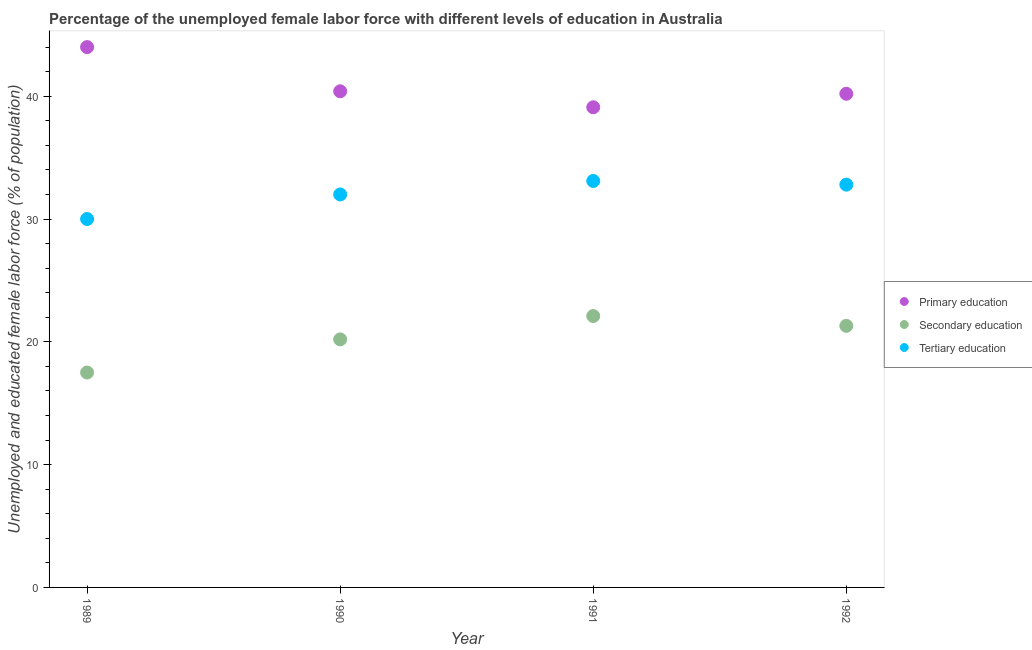What is the percentage of female labor force who received secondary education in 1990?
Keep it short and to the point. 20.2. Across all years, what is the maximum percentage of female labor force who received secondary education?
Provide a succinct answer. 22.1. Across all years, what is the minimum percentage of female labor force who received tertiary education?
Your response must be concise. 30. In which year was the percentage of female labor force who received secondary education maximum?
Make the answer very short. 1991. What is the total percentage of female labor force who received tertiary education in the graph?
Offer a very short reply. 127.9. What is the difference between the percentage of female labor force who received secondary education in 1989 and that in 1992?
Provide a succinct answer. -3.8. What is the difference between the percentage of female labor force who received tertiary education in 1990 and the percentage of female labor force who received secondary education in 1992?
Keep it short and to the point. 10.7. What is the average percentage of female labor force who received primary education per year?
Keep it short and to the point. 40.93. In the year 1992, what is the difference between the percentage of female labor force who received secondary education and percentage of female labor force who received primary education?
Your answer should be very brief. -18.9. In how many years, is the percentage of female labor force who received tertiary education greater than 10 %?
Your answer should be compact. 4. What is the ratio of the percentage of female labor force who received primary education in 1989 to that in 1992?
Your response must be concise. 1.09. Is the percentage of female labor force who received secondary education in 1990 less than that in 1992?
Your response must be concise. Yes. Is the difference between the percentage of female labor force who received primary education in 1989 and 1990 greater than the difference between the percentage of female labor force who received secondary education in 1989 and 1990?
Give a very brief answer. Yes. What is the difference between the highest and the second highest percentage of female labor force who received tertiary education?
Ensure brevity in your answer.  0.3. What is the difference between the highest and the lowest percentage of female labor force who received tertiary education?
Provide a succinct answer. 3.1. Is it the case that in every year, the sum of the percentage of female labor force who received primary education and percentage of female labor force who received secondary education is greater than the percentage of female labor force who received tertiary education?
Provide a short and direct response. Yes. How many years are there in the graph?
Your response must be concise. 4. What is the difference between two consecutive major ticks on the Y-axis?
Give a very brief answer. 10. Are the values on the major ticks of Y-axis written in scientific E-notation?
Your answer should be very brief. No. Where does the legend appear in the graph?
Your response must be concise. Center right. How many legend labels are there?
Ensure brevity in your answer.  3. How are the legend labels stacked?
Provide a short and direct response. Vertical. What is the title of the graph?
Your answer should be very brief. Percentage of the unemployed female labor force with different levels of education in Australia. Does "Errors" appear as one of the legend labels in the graph?
Make the answer very short. No. What is the label or title of the X-axis?
Give a very brief answer. Year. What is the label or title of the Y-axis?
Your response must be concise. Unemployed and educated female labor force (% of population). What is the Unemployed and educated female labor force (% of population) of Tertiary education in 1989?
Offer a terse response. 30. What is the Unemployed and educated female labor force (% of population) of Primary education in 1990?
Offer a terse response. 40.4. What is the Unemployed and educated female labor force (% of population) in Secondary education in 1990?
Your answer should be very brief. 20.2. What is the Unemployed and educated female labor force (% of population) in Primary education in 1991?
Offer a terse response. 39.1. What is the Unemployed and educated female labor force (% of population) in Secondary education in 1991?
Provide a short and direct response. 22.1. What is the Unemployed and educated female labor force (% of population) of Tertiary education in 1991?
Your answer should be compact. 33.1. What is the Unemployed and educated female labor force (% of population) in Primary education in 1992?
Provide a short and direct response. 40.2. What is the Unemployed and educated female labor force (% of population) of Secondary education in 1992?
Your answer should be compact. 21.3. What is the Unemployed and educated female labor force (% of population) of Tertiary education in 1992?
Keep it short and to the point. 32.8. Across all years, what is the maximum Unemployed and educated female labor force (% of population) of Primary education?
Offer a very short reply. 44. Across all years, what is the maximum Unemployed and educated female labor force (% of population) of Secondary education?
Provide a short and direct response. 22.1. Across all years, what is the maximum Unemployed and educated female labor force (% of population) of Tertiary education?
Your answer should be very brief. 33.1. Across all years, what is the minimum Unemployed and educated female labor force (% of population) in Primary education?
Offer a very short reply. 39.1. Across all years, what is the minimum Unemployed and educated female labor force (% of population) of Secondary education?
Offer a terse response. 17.5. Across all years, what is the minimum Unemployed and educated female labor force (% of population) in Tertiary education?
Your answer should be very brief. 30. What is the total Unemployed and educated female labor force (% of population) of Primary education in the graph?
Offer a very short reply. 163.7. What is the total Unemployed and educated female labor force (% of population) in Secondary education in the graph?
Provide a succinct answer. 81.1. What is the total Unemployed and educated female labor force (% of population) in Tertiary education in the graph?
Provide a short and direct response. 127.9. What is the difference between the Unemployed and educated female labor force (% of population) of Primary education in 1989 and that in 1992?
Ensure brevity in your answer.  3.8. What is the difference between the Unemployed and educated female labor force (% of population) of Secondary education in 1989 and that in 1992?
Give a very brief answer. -3.8. What is the difference between the Unemployed and educated female labor force (% of population) of Tertiary education in 1989 and that in 1992?
Ensure brevity in your answer.  -2.8. What is the difference between the Unemployed and educated female labor force (% of population) of Primary education in 1990 and that in 1991?
Give a very brief answer. 1.3. What is the difference between the Unemployed and educated female labor force (% of population) in Tertiary education in 1990 and that in 1991?
Ensure brevity in your answer.  -1.1. What is the difference between the Unemployed and educated female labor force (% of population) in Primary education in 1990 and that in 1992?
Keep it short and to the point. 0.2. What is the difference between the Unemployed and educated female labor force (% of population) of Tertiary education in 1990 and that in 1992?
Make the answer very short. -0.8. What is the difference between the Unemployed and educated female labor force (% of population) of Primary education in 1989 and the Unemployed and educated female labor force (% of population) of Secondary education in 1990?
Provide a succinct answer. 23.8. What is the difference between the Unemployed and educated female labor force (% of population) in Secondary education in 1989 and the Unemployed and educated female labor force (% of population) in Tertiary education in 1990?
Ensure brevity in your answer.  -14.5. What is the difference between the Unemployed and educated female labor force (% of population) in Primary education in 1989 and the Unemployed and educated female labor force (% of population) in Secondary education in 1991?
Provide a succinct answer. 21.9. What is the difference between the Unemployed and educated female labor force (% of population) in Secondary education in 1989 and the Unemployed and educated female labor force (% of population) in Tertiary education in 1991?
Ensure brevity in your answer.  -15.6. What is the difference between the Unemployed and educated female labor force (% of population) in Primary education in 1989 and the Unemployed and educated female labor force (% of population) in Secondary education in 1992?
Keep it short and to the point. 22.7. What is the difference between the Unemployed and educated female labor force (% of population) in Primary education in 1989 and the Unemployed and educated female labor force (% of population) in Tertiary education in 1992?
Provide a succinct answer. 11.2. What is the difference between the Unemployed and educated female labor force (% of population) of Secondary education in 1989 and the Unemployed and educated female labor force (% of population) of Tertiary education in 1992?
Offer a terse response. -15.3. What is the difference between the Unemployed and educated female labor force (% of population) of Primary education in 1990 and the Unemployed and educated female labor force (% of population) of Tertiary education in 1992?
Provide a short and direct response. 7.6. What is the average Unemployed and educated female labor force (% of population) of Primary education per year?
Your answer should be compact. 40.92. What is the average Unemployed and educated female labor force (% of population) in Secondary education per year?
Your response must be concise. 20.27. What is the average Unemployed and educated female labor force (% of population) of Tertiary education per year?
Provide a short and direct response. 31.98. In the year 1989, what is the difference between the Unemployed and educated female labor force (% of population) in Primary education and Unemployed and educated female labor force (% of population) in Secondary education?
Your answer should be compact. 26.5. In the year 1989, what is the difference between the Unemployed and educated female labor force (% of population) of Primary education and Unemployed and educated female labor force (% of population) of Tertiary education?
Your response must be concise. 14. In the year 1989, what is the difference between the Unemployed and educated female labor force (% of population) in Secondary education and Unemployed and educated female labor force (% of population) in Tertiary education?
Give a very brief answer. -12.5. In the year 1990, what is the difference between the Unemployed and educated female labor force (% of population) in Primary education and Unemployed and educated female labor force (% of population) in Secondary education?
Your response must be concise. 20.2. In the year 1991, what is the difference between the Unemployed and educated female labor force (% of population) of Primary education and Unemployed and educated female labor force (% of population) of Secondary education?
Provide a short and direct response. 17. In the year 1991, what is the difference between the Unemployed and educated female labor force (% of population) in Primary education and Unemployed and educated female labor force (% of population) in Tertiary education?
Provide a short and direct response. 6. In the year 1992, what is the difference between the Unemployed and educated female labor force (% of population) in Primary education and Unemployed and educated female labor force (% of population) in Secondary education?
Provide a succinct answer. 18.9. What is the ratio of the Unemployed and educated female labor force (% of population) of Primary education in 1989 to that in 1990?
Keep it short and to the point. 1.09. What is the ratio of the Unemployed and educated female labor force (% of population) in Secondary education in 1989 to that in 1990?
Your answer should be compact. 0.87. What is the ratio of the Unemployed and educated female labor force (% of population) in Tertiary education in 1989 to that in 1990?
Provide a short and direct response. 0.94. What is the ratio of the Unemployed and educated female labor force (% of population) in Primary education in 1989 to that in 1991?
Keep it short and to the point. 1.13. What is the ratio of the Unemployed and educated female labor force (% of population) in Secondary education in 1989 to that in 1991?
Make the answer very short. 0.79. What is the ratio of the Unemployed and educated female labor force (% of population) of Tertiary education in 1989 to that in 1991?
Make the answer very short. 0.91. What is the ratio of the Unemployed and educated female labor force (% of population) of Primary education in 1989 to that in 1992?
Your response must be concise. 1.09. What is the ratio of the Unemployed and educated female labor force (% of population) of Secondary education in 1989 to that in 1992?
Provide a succinct answer. 0.82. What is the ratio of the Unemployed and educated female labor force (% of population) of Tertiary education in 1989 to that in 1992?
Provide a succinct answer. 0.91. What is the ratio of the Unemployed and educated female labor force (% of population) in Primary education in 1990 to that in 1991?
Provide a succinct answer. 1.03. What is the ratio of the Unemployed and educated female labor force (% of population) of Secondary education in 1990 to that in 1991?
Your answer should be very brief. 0.91. What is the ratio of the Unemployed and educated female labor force (% of population) of Tertiary education in 1990 to that in 1991?
Your response must be concise. 0.97. What is the ratio of the Unemployed and educated female labor force (% of population) of Primary education in 1990 to that in 1992?
Your answer should be compact. 1. What is the ratio of the Unemployed and educated female labor force (% of population) in Secondary education in 1990 to that in 1992?
Offer a very short reply. 0.95. What is the ratio of the Unemployed and educated female labor force (% of population) in Tertiary education in 1990 to that in 1992?
Offer a terse response. 0.98. What is the ratio of the Unemployed and educated female labor force (% of population) in Primary education in 1991 to that in 1992?
Provide a succinct answer. 0.97. What is the ratio of the Unemployed and educated female labor force (% of population) of Secondary education in 1991 to that in 1992?
Offer a very short reply. 1.04. What is the ratio of the Unemployed and educated female labor force (% of population) in Tertiary education in 1991 to that in 1992?
Offer a very short reply. 1.01. What is the difference between the highest and the second highest Unemployed and educated female labor force (% of population) of Tertiary education?
Keep it short and to the point. 0.3. 